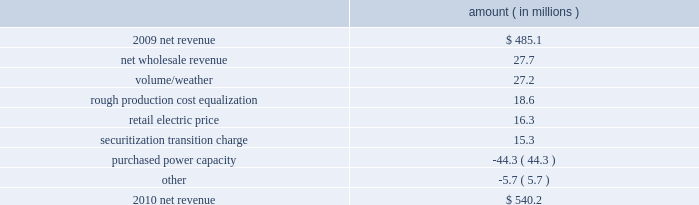Entergy texas , inc .
And subsidiaries management 2019s financial discussion and analysis gross operating revenues , fuel and purchased power expenses , and other regulatory charges gross operating revenues increased primarily due to the base rate increases and the volume/weather effect , as discussed above .
Fuel and purchased power expenses increased primarily due to an increase in demand coupled with an increase in deferred fuel expense as a result of lower fuel refunds in 2011 versus 2010 , partially offset by a decrease in the average market price of natural gas .
Other regulatory charges decreased primarily due to the distribution in the first quarter 2011 of $ 17.4 million to customers of the 2007 rough production cost equalization remedy receipts .
See note 2 to the financial statements for further discussion of the rough production cost equalization proceedings .
2010 compared to 2009 net revenue consists of operating revenues net of : 1 ) fuel , fuel-related expenses , and gas purchased for resale , 2 ) purchased power expenses , and 3 ) other regulatory charges ( credits ) .
Following is an analysis of the change in net revenue comparing 2010 to 2009 .
Amount ( in millions ) .
The net wholesale revenue variance is primarily due to increased sales to municipal and co-op customers due to the addition of new contracts .
The volume/weather variance is primarily due to increased electricity usage primarily in the residential and commercial sectors , resulting from a 1.5% ( 1.5 % ) increase in customers , coupled with the effect of more favorable weather on residential sales .
Billed electricity usage increased a total of 777 gwh , or 5% ( 5 % ) .
The rough production cost equalization variance is due to an additional $ 18.6 million allocation recorded in the second quarter of 2009 for 2007 rough production cost equalization receipts ordered by the puct to texas retail customers over what was originally allocated to entergy texas prior to the jurisdictional separation of entergy gulf states , inc .
Into entergy gulf states louisiana and entergy texas , effective december 2007 , as discussed in note 2 to the financial statements .
The retail electric price variance is primarily due to rate actions , including an annual base rate increase of $ 59 million beginning august 2010 as a result of the settlement of the december 2009 rate case .
See note 2 to the financial statements for further discussion of the rate case settlement .
The securitization transition charge variance is due to the issuance of securitization bonds .
In november 2009 , entergy texas restoration funding , llc , a company wholly-owned and consolidated by entergy texas , issued securitization bonds and with the proceeds purchased from entergy texas the transition property , which is the right to recover from customers through a transition charge amounts sufficient to service the securitization bonds .
The securitization transition charge is offset with a corresponding increase in interest on long-term debt with no impact on net income .
See note 5 to the financial statements for further discussion of the securitization bond issuance. .
What is the growth rate in net revenue from 2009 to 2010? 
Computations: ((540.2 - 485.1) / 485.1)
Answer: 0.11358. 